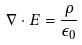<formula> <loc_0><loc_0><loc_500><loc_500>\nabla \cdot E = \frac { \rho } { \epsilon _ { 0 } }</formula> 